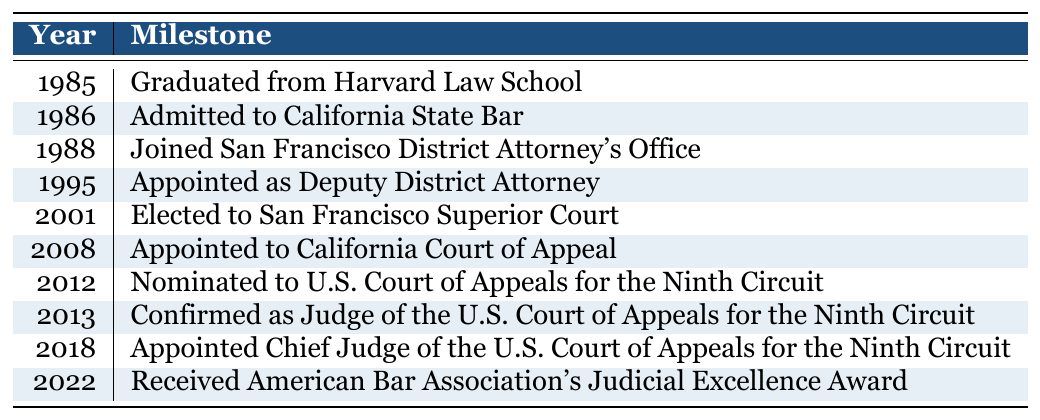What year did Judge Hsu graduate from Harvard Law School? The table lists the significant milestones in Judge Hsu's career. According to the table, the event of graduating from Harvard Law School is noted in the year 1985.
Answer: 1985 What event happened immediately after Judge Hsu was admitted to the California State Bar? The table indicates that Judge Hsu was admitted to the California State Bar in 1986 and subsequently joined the San Francisco District Attorney's Office in 1988. Therefore, the event that happened immediately after was joining the District Attorney's Office.
Answer: Joined San Francisco District Attorney's Office How many years after being appointed as Deputy District Attorney did Judge Hsu get elected to San Francisco Superior Court? Judge Hsu was appointed as Deputy District Attorney in 1995 and elected to San Francisco Superior Court in 2001. The difference in years is 2001 - 1995, which is 6 years.
Answer: 6 years Did Judge Hsu serve in the U.S. Court of Appeals for the Ninth Circuit before becoming the Chief Judge? The table shows that Judge Hsu was confirmed as a judge of the U.S. Court of Appeals for the Ninth Circuit in 2013 and appointed Chief Judge in 2018. Since 2013 is before 2018, the answer is yes.
Answer: Yes What is the span of years between Judge Hsu’s graduation from Harvard Law School and receiving the American Bar Association's Judicial Excellence Award? Judge Hsu graduated from Harvard Law School in 1985 and received the American Bar Association's Judicial Excellence Award in 2022. To find the span, subtract 1985 from 2022, which is 2022 - 1985 = 37 years.
Answer: 37 years What percentage of the milestones listed were completed by 2008? There are a total of 10 milestones. By 2008, Judge Hsu had completed 6 milestones (up to the appointment to the California Court of Appeal). To find the percentage, compute (6 milestones / 10 total milestones) * 100, which equals 60%.
Answer: 60% Which significant milestone is chronologically right before Judge Hsu was appointed Chief Judge of the U.S. Court of Appeals? The table shows that he was confirmed as Judge of the U.S. Court of Appeals for the Ninth Circuit in 2013, and the next milestone, which was his appointment as Chief Judge, occurred in 2018. Thus, the milestone right before his appointment as Chief Judge was his confirmation.
Answer: Confirmed as Judge of the U.S. Court of Appeals for the Ninth Circuit Was there a period of three years without any major milestones between 2001 and 2008? From 2001 (elected to San Francisco Superior Court) to 2008 (appointed to California Court of Appeal), there are indeed three major milestones years (2002, 2003, and 2004) without any events listed. Therefore, the answer is yes.
Answer: Yes 